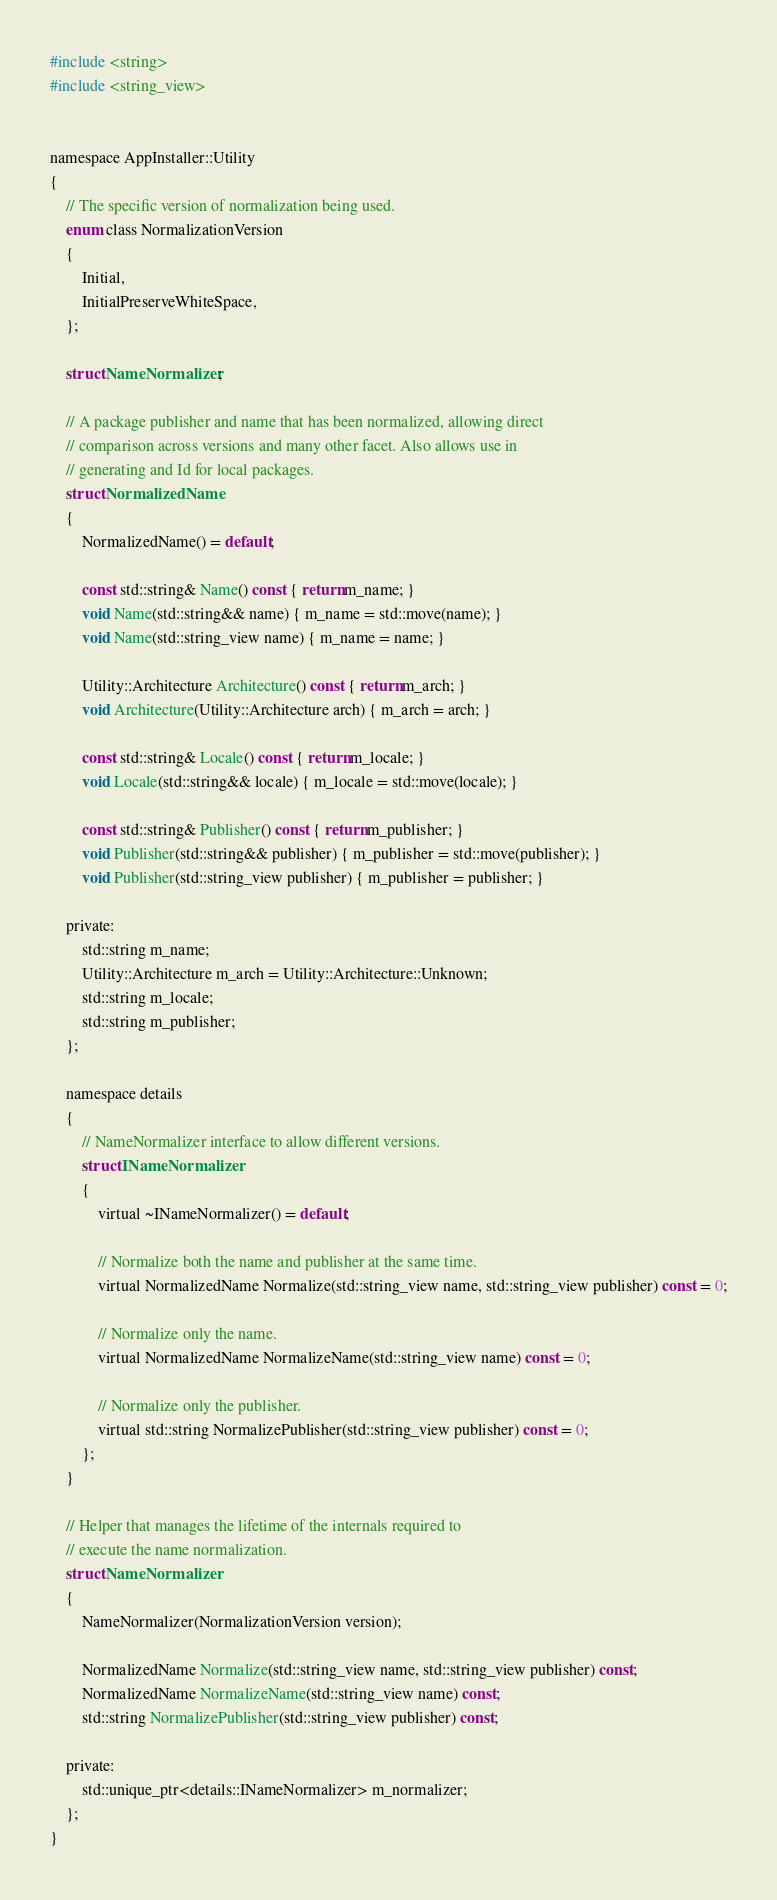Convert code to text. <code><loc_0><loc_0><loc_500><loc_500><_C_>#include <string>
#include <string_view>


namespace AppInstaller::Utility
{
    // The specific version of normalization being used.
    enum class NormalizationVersion
    {
        Initial,
        InitialPreserveWhiteSpace,
    };

    struct NameNormalizer;

    // A package publisher and name that has been normalized, allowing direct
    // comparison across versions and many other facet. Also allows use in
    // generating and Id for local packages.
    struct NormalizedName
    {
        NormalizedName() = default;

        const std::string& Name() const { return m_name; }
        void Name(std::string&& name) { m_name = std::move(name); }
        void Name(std::string_view name) { m_name = name; }

        Utility::Architecture Architecture() const { return m_arch; }
        void Architecture(Utility::Architecture arch) { m_arch = arch; }

        const std::string& Locale() const { return m_locale; }
        void Locale(std::string&& locale) { m_locale = std::move(locale); }

        const std::string& Publisher() const { return m_publisher; }
        void Publisher(std::string&& publisher) { m_publisher = std::move(publisher); }
        void Publisher(std::string_view publisher) { m_publisher = publisher; }

    private:
        std::string m_name;
        Utility::Architecture m_arch = Utility::Architecture::Unknown;
        std::string m_locale;
        std::string m_publisher;
    };

    namespace details
    {
        // NameNormalizer interface to allow different versions.
        struct INameNormalizer
        {
            virtual ~INameNormalizer() = default;

            // Normalize both the name and publisher at the same time.
            virtual NormalizedName Normalize(std::string_view name, std::string_view publisher) const = 0;

            // Normalize only the name.
            virtual NormalizedName NormalizeName(std::string_view name) const = 0;

            // Normalize only the publisher.
            virtual std::string NormalizePublisher(std::string_view publisher) const = 0;
        };
    }

    // Helper that manages the lifetime of the internals required to
    // execute the name normalization.
    struct NameNormalizer
    {
        NameNormalizer(NormalizationVersion version);

        NormalizedName Normalize(std::string_view name, std::string_view publisher) const;
        NormalizedName NormalizeName(std::string_view name) const;
        std::string NormalizePublisher(std::string_view publisher) const;

    private:
        std::unique_ptr<details::INameNormalizer> m_normalizer;
    };
}
</code> 